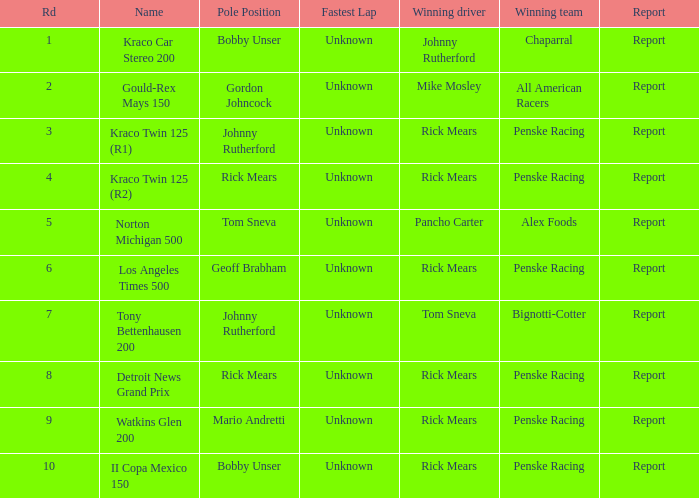Which races has johnny rutherford been victorious in? Kraco Car Stereo 200. 